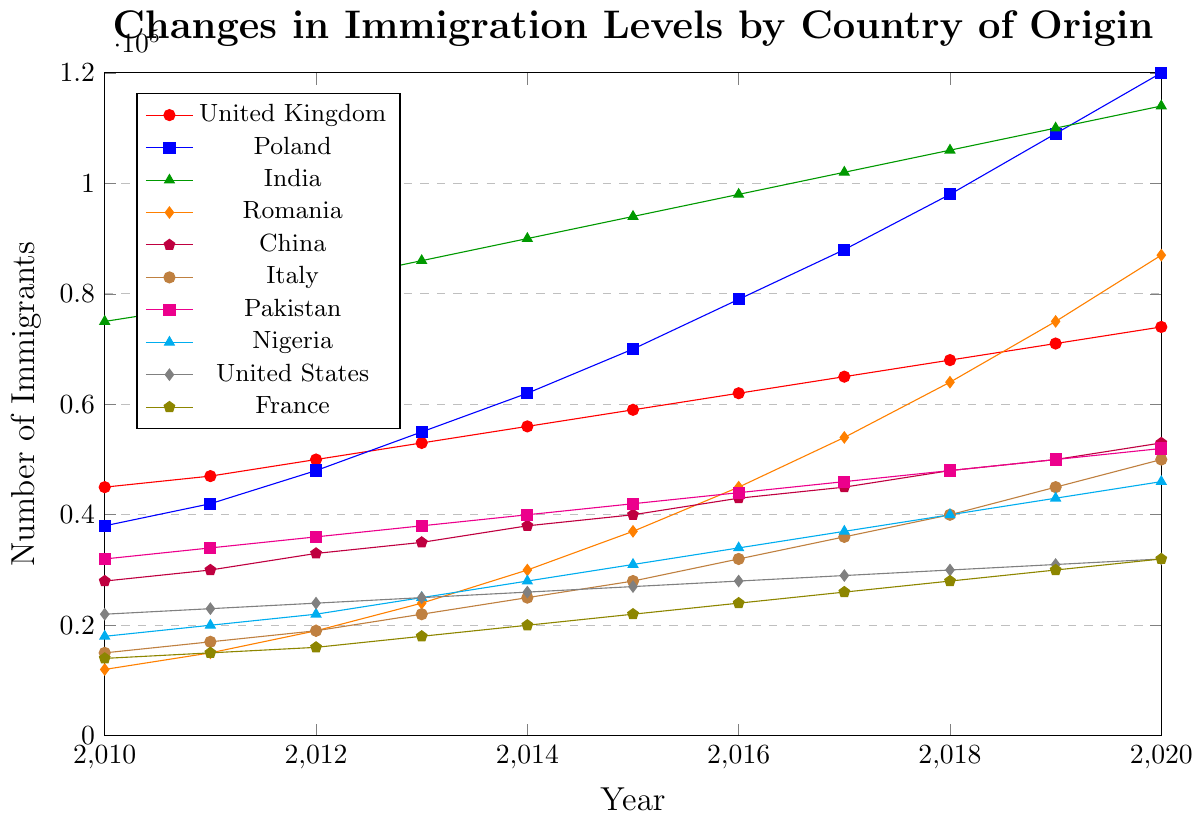What year did the number of immigrants from the United Kingdom surpass 60,000? To identify the year when the number of immigrants from the United Kingdom surpassed 60,000, we examine the data line for the United Kingdom. Tracking the data points, it is apparent that the count surpasses 60,000 in the year 2016, where it hits 62,000.
Answer: 2016 Which country saw the highest increase in immigration levels from 2010 to 2020? To determine which country experienced the greatest increase, we need to look at the immigration figures for each country in 2010 and 2020, then calculate the difference. India sees an increase from 75,000 in 2010 to 114,000 in 2020, an increase of 39,000. Comparing all countries, Poland's numbers increased from 38,000 in 2010 to 120,000 in 2020, an increase of 82,000, the largest among all.
Answer: Poland What is the average number of immigrants from China from 2010 to 2020? To find the average, we sum the data points for China from 2010 to 2020: (28,000 + 30,000 + 33,000 + 35,000 + 38,000 + 40,000 + 43,000 + 45,000 + 48,000 + 50,000 + 53,000) = 435,000, and then divide by the number of years (11).
Answer: 39,545 Which two countries had the closest immigration levels in 2020? In 2020, the immigrant levels are: United Kingdom (74,000), Poland (120,000), India (114,000), Romania (87,000), China (53,000), Italy (50,000), Pakistan (52,000), Nigeria (46,000), United States (32,000), France (32,000). Comparing these values, Nigeria and Pakistan had very close immigration levels of 46,000 and 52,000, respectively.
Answer: Nigeria and Pakistan From which year did Romania begin to see a rapid increase in immigration that continued through 2020? Observing Romania's immigration line, the increase becomes notably rapid starting from 2015 with 37,000 and continuing upward each subsequent year, indicating a rapid and sustained increase.
Answer: 2015 Which country had the least increase in immigration numbers from 2010 to 2020? By finding the change in immigration numbers from 2010 to 2020 for each country, we get: France (18,000), United States (10,000), Nigeria (28,000), Pakistan (20,000), Italy (35,000), China (25,000), Romania (75,000), India (39,000), Poland (82,000), United Kingdom (29,000). The United States had the least increase of 10,000.
Answer: United States Which country had the highest number of immigrants in 2018 and what was the value? To find the highest number of immigrants in 2018, we examine the data: United Kingdom (68,000), Poland (98,000), India (106,000), Romania (64,000), China (48,000), Italy (40,000), Pakistan (48,000), Nigeria (40,000), United States (30,000), France (28,000). India had the highest with 106,000 immigrants.
Answer: India, 106,000 